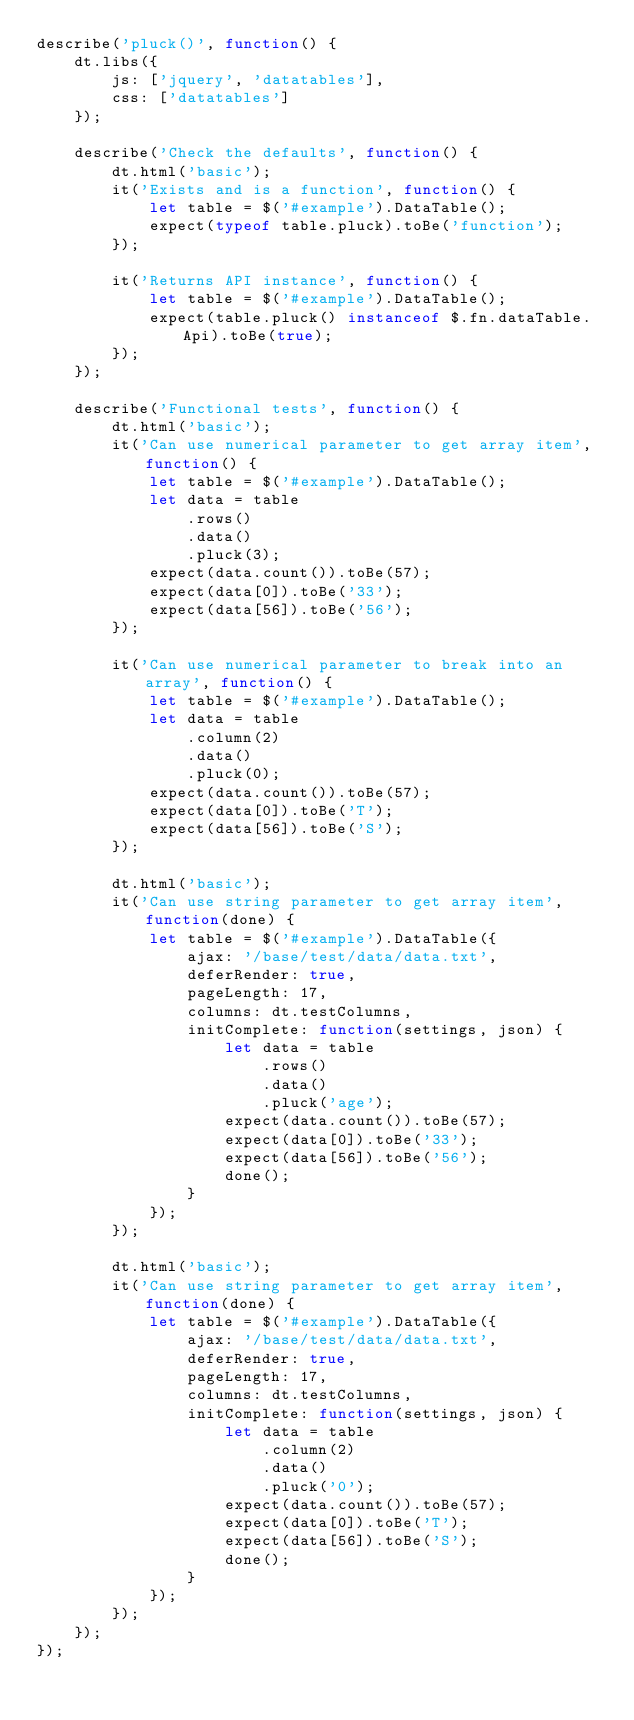<code> <loc_0><loc_0><loc_500><loc_500><_JavaScript_>describe('pluck()', function() {
	dt.libs({
		js: ['jquery', 'datatables'],
		css: ['datatables']
	});

	describe('Check the defaults', function() {
		dt.html('basic');
		it('Exists and is a function', function() {
			let table = $('#example').DataTable();
			expect(typeof table.pluck).toBe('function');
		});

		it('Returns API instance', function() {
			let table = $('#example').DataTable();
			expect(table.pluck() instanceof $.fn.dataTable.Api).toBe(true);
		});
	});

	describe('Functional tests', function() {
		dt.html('basic');
		it('Can use numerical parameter to get array item', function() {
			let table = $('#example').DataTable();
			let data = table
				.rows()
				.data()
				.pluck(3);
			expect(data.count()).toBe(57);
			expect(data[0]).toBe('33');
			expect(data[56]).toBe('56');
		});

		it('Can use numerical parameter to break into an array', function() {
			let table = $('#example').DataTable();
			let data = table
				.column(2)
				.data()
				.pluck(0);
			expect(data.count()).toBe(57);
			expect(data[0]).toBe('T');
			expect(data[56]).toBe('S');
		});

		dt.html('basic');
		it('Can use string parameter to get array item', function(done) {
			let table = $('#example').DataTable({
				ajax: '/base/test/data/data.txt',
				deferRender: true,
				pageLength: 17,
				columns: dt.testColumns,
				initComplete: function(settings, json) {
					let data = table
						.rows()
						.data()
						.pluck('age');
					expect(data.count()).toBe(57);
					expect(data[0]).toBe('33');
					expect(data[56]).toBe('56');
					done();
				}
			});
		});

		dt.html('basic');
		it('Can use string parameter to get array item', function(done) {
			let table = $('#example').DataTable({
				ajax: '/base/test/data/data.txt',
				deferRender: true,
				pageLength: 17,
				columns: dt.testColumns,
				initComplete: function(settings, json) {
					let data = table
						.column(2)
						.data()
						.pluck('0');
					expect(data.count()).toBe(57);
					expect(data[0]).toBe('T');
					expect(data[56]).toBe('S');
					done();
				}
			});
		});
	});
});
</code> 